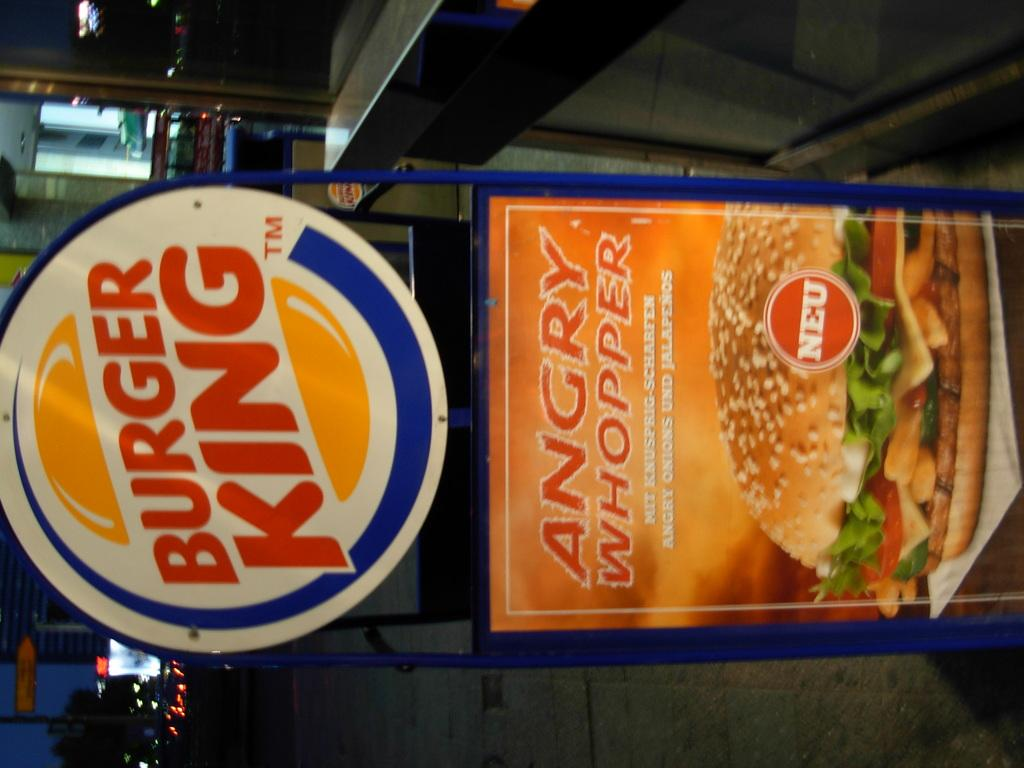What type of structure is visible in the image? There is a metal cabin in the image. What is located at the top of the image? There is a counter top at the top of the image. Are there any turkeys visible in the image? No, there are no turkeys present in the image. Can you see any fairies flying around the metal cabin in the image? No, there are no fairies present in the image. 